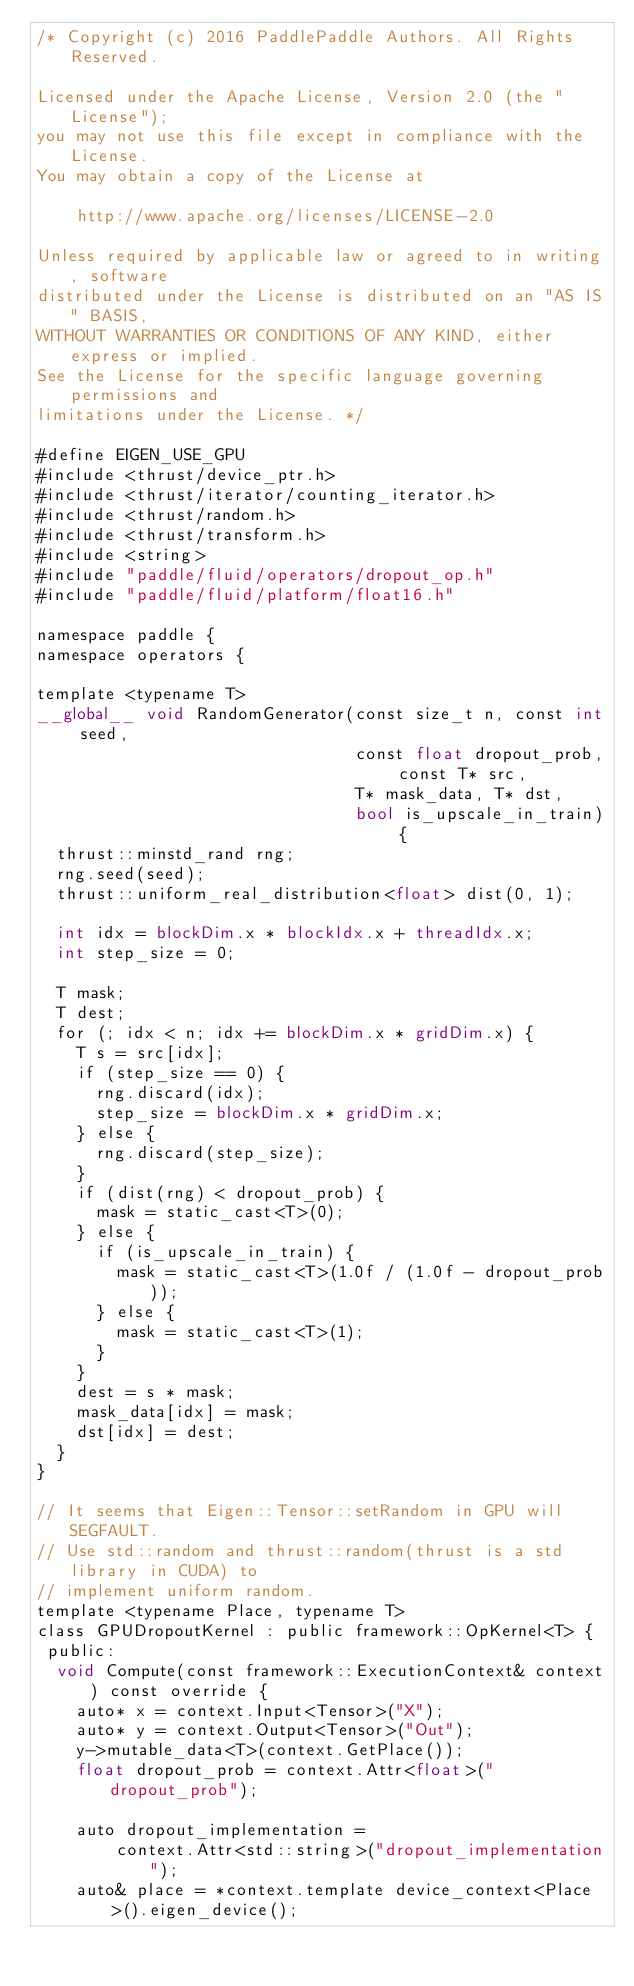<code> <loc_0><loc_0><loc_500><loc_500><_Cuda_>/* Copyright (c) 2016 PaddlePaddle Authors. All Rights Reserved.

Licensed under the Apache License, Version 2.0 (the "License");
you may not use this file except in compliance with the License.
You may obtain a copy of the License at

    http://www.apache.org/licenses/LICENSE-2.0

Unless required by applicable law or agreed to in writing, software
distributed under the License is distributed on an "AS IS" BASIS,
WITHOUT WARRANTIES OR CONDITIONS OF ANY KIND, either express or implied.
See the License for the specific language governing permissions and
limitations under the License. */

#define EIGEN_USE_GPU
#include <thrust/device_ptr.h>
#include <thrust/iterator/counting_iterator.h>
#include <thrust/random.h>
#include <thrust/transform.h>
#include <string>
#include "paddle/fluid/operators/dropout_op.h"
#include "paddle/fluid/platform/float16.h"

namespace paddle {
namespace operators {

template <typename T>
__global__ void RandomGenerator(const size_t n, const int seed,
                                const float dropout_prob, const T* src,
                                T* mask_data, T* dst,
                                bool is_upscale_in_train) {
  thrust::minstd_rand rng;
  rng.seed(seed);
  thrust::uniform_real_distribution<float> dist(0, 1);

  int idx = blockDim.x * blockIdx.x + threadIdx.x;
  int step_size = 0;

  T mask;
  T dest;
  for (; idx < n; idx += blockDim.x * gridDim.x) {
    T s = src[idx];
    if (step_size == 0) {
      rng.discard(idx);
      step_size = blockDim.x * gridDim.x;
    } else {
      rng.discard(step_size);
    }
    if (dist(rng) < dropout_prob) {
      mask = static_cast<T>(0);
    } else {
      if (is_upscale_in_train) {
        mask = static_cast<T>(1.0f / (1.0f - dropout_prob));
      } else {
        mask = static_cast<T>(1);
      }
    }
    dest = s * mask;
    mask_data[idx] = mask;
    dst[idx] = dest;
  }
}

// It seems that Eigen::Tensor::setRandom in GPU will SEGFAULT.
// Use std::random and thrust::random(thrust is a std library in CUDA) to
// implement uniform random.
template <typename Place, typename T>
class GPUDropoutKernel : public framework::OpKernel<T> {
 public:
  void Compute(const framework::ExecutionContext& context) const override {
    auto* x = context.Input<Tensor>("X");
    auto* y = context.Output<Tensor>("Out");
    y->mutable_data<T>(context.GetPlace());
    float dropout_prob = context.Attr<float>("dropout_prob");

    auto dropout_implementation =
        context.Attr<std::string>("dropout_implementation");
    auto& place = *context.template device_context<Place>().eigen_device();</code> 